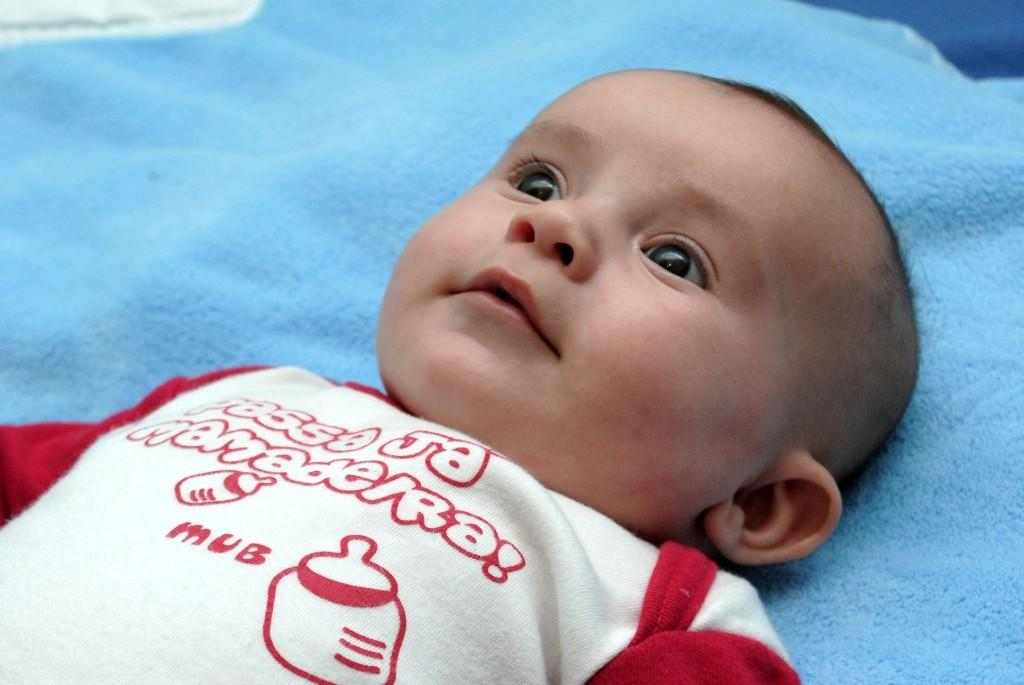What is the main subject of the image? The main subject of the image is a baby. Where is the baby located in the image? The baby is laying on a bed. What type of magic is the baby performing in the image? There is no magic or any indication of magic in the image; it simply shows a baby laying on a bed. 